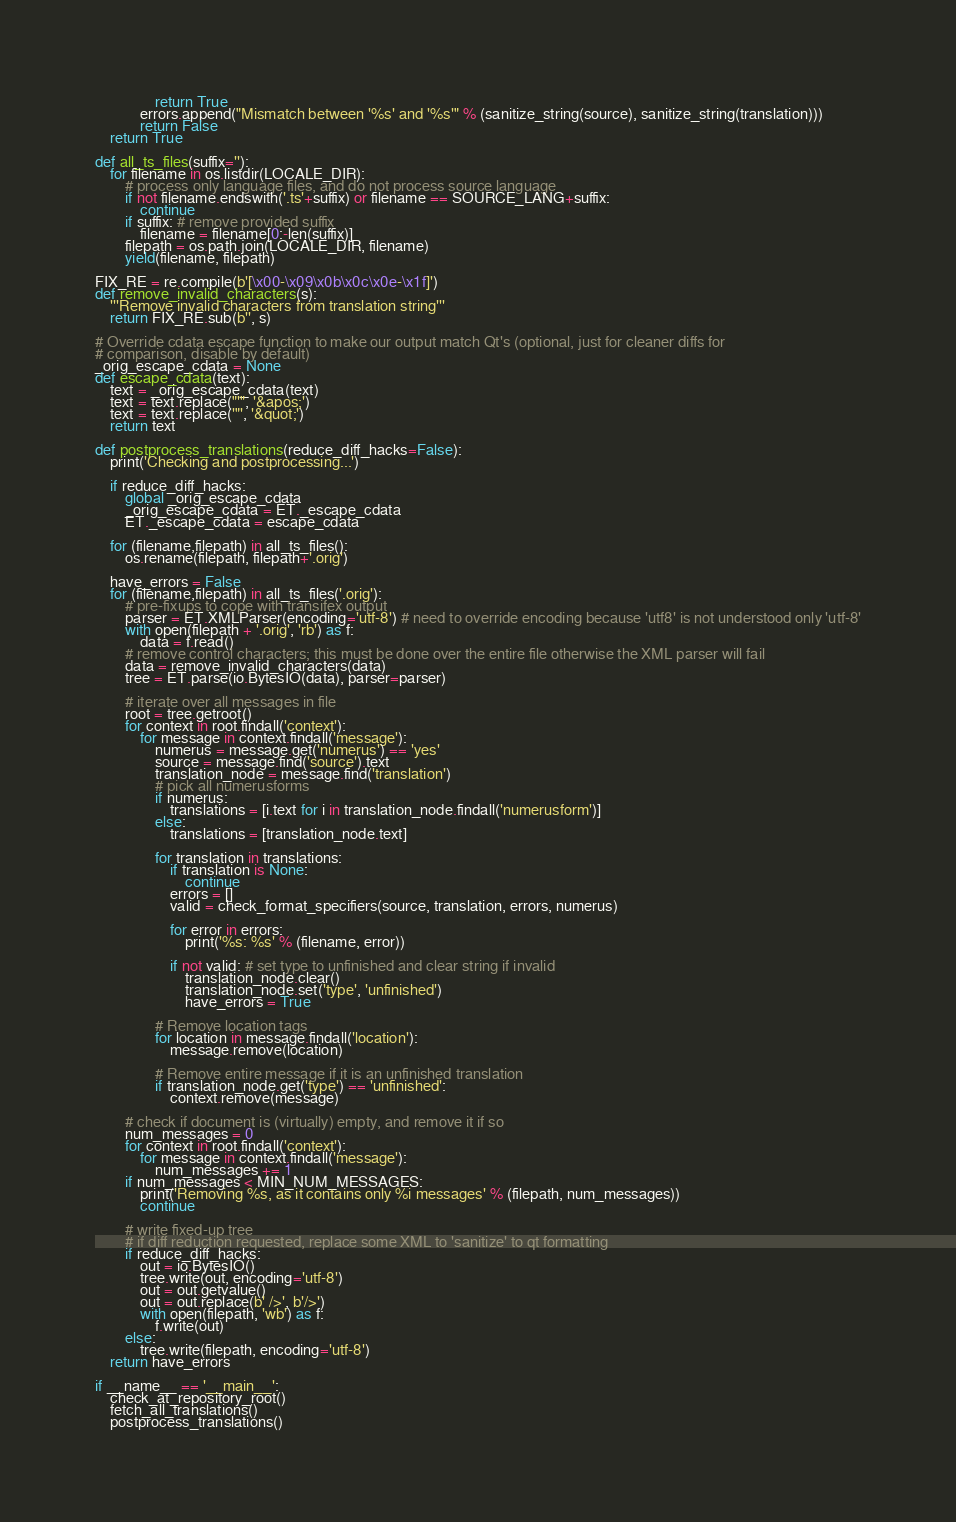<code> <loc_0><loc_0><loc_500><loc_500><_Python_>                return True
            errors.append("Mismatch between '%s' and '%s'" % (sanitize_string(source), sanitize_string(translation)))
            return False
    return True

def all_ts_files(suffix=''):
    for filename in os.listdir(LOCALE_DIR):
        # process only language files, and do not process source language
        if not filename.endswith('.ts'+suffix) or filename == SOURCE_LANG+suffix:
            continue
        if suffix: # remove provided suffix
            filename = filename[0:-len(suffix)]
        filepath = os.path.join(LOCALE_DIR, filename)
        yield(filename, filepath)

FIX_RE = re.compile(b'[\x00-\x09\x0b\x0c\x0e-\x1f]')
def remove_invalid_characters(s):
    '''Remove invalid characters from translation string'''
    return FIX_RE.sub(b'', s)

# Override cdata escape function to make our output match Qt's (optional, just for cleaner diffs for
# comparison, disable by default)
_orig_escape_cdata = None
def escape_cdata(text):
    text = _orig_escape_cdata(text)
    text = text.replace("'", '&apos;')
    text = text.replace('"', '&quot;')
    return text

def postprocess_translations(reduce_diff_hacks=False):
    print('Checking and postprocessing...')

    if reduce_diff_hacks:
        global _orig_escape_cdata
        _orig_escape_cdata = ET._escape_cdata
        ET._escape_cdata = escape_cdata

    for (filename,filepath) in all_ts_files():
        os.rename(filepath, filepath+'.orig')

    have_errors = False
    for (filename,filepath) in all_ts_files('.orig'):
        # pre-fixups to cope with transifex output
        parser = ET.XMLParser(encoding='utf-8') # need to override encoding because 'utf8' is not understood only 'utf-8'
        with open(filepath + '.orig', 'rb') as f:
            data = f.read()
        # remove control characters; this must be done over the entire file otherwise the XML parser will fail
        data = remove_invalid_characters(data)
        tree = ET.parse(io.BytesIO(data), parser=parser)

        # iterate over all messages in file
        root = tree.getroot()
        for context in root.findall('context'):
            for message in context.findall('message'):
                numerus = message.get('numerus') == 'yes'
                source = message.find('source').text
                translation_node = message.find('translation')
                # pick all numerusforms
                if numerus:
                    translations = [i.text for i in translation_node.findall('numerusform')]
                else:
                    translations = [translation_node.text]

                for translation in translations:
                    if translation is None:
                        continue
                    errors = []
                    valid = check_format_specifiers(source, translation, errors, numerus)

                    for error in errors:
                        print('%s: %s' % (filename, error))

                    if not valid: # set type to unfinished and clear string if invalid
                        translation_node.clear()
                        translation_node.set('type', 'unfinished')
                        have_errors = True

                # Remove location tags
                for location in message.findall('location'):
                    message.remove(location)

                # Remove entire message if it is an unfinished translation
                if translation_node.get('type') == 'unfinished':
                    context.remove(message)

        # check if document is (virtually) empty, and remove it if so
        num_messages = 0
        for context in root.findall('context'):
            for message in context.findall('message'):
                num_messages += 1
        if num_messages < MIN_NUM_MESSAGES:
            print('Removing %s, as it contains only %i messages' % (filepath, num_messages))
            continue

        # write fixed-up tree
        # if diff reduction requested, replace some XML to 'sanitize' to qt formatting
        if reduce_diff_hacks:
            out = io.BytesIO()
            tree.write(out, encoding='utf-8')
            out = out.getvalue()
            out = out.replace(b' />', b'/>')
            with open(filepath, 'wb') as f:
                f.write(out)
        else:
            tree.write(filepath, encoding='utf-8')
    return have_errors

if __name__ == '__main__':
    check_at_repository_root()
    fetch_all_translations()
    postprocess_translations()
</code> 